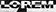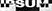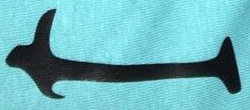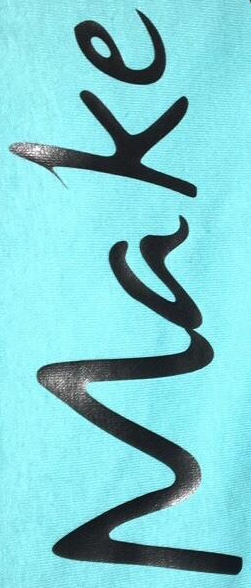Read the text content from these images in order, separated by a semicolon. LOPEM; IPSUM; I; Make 